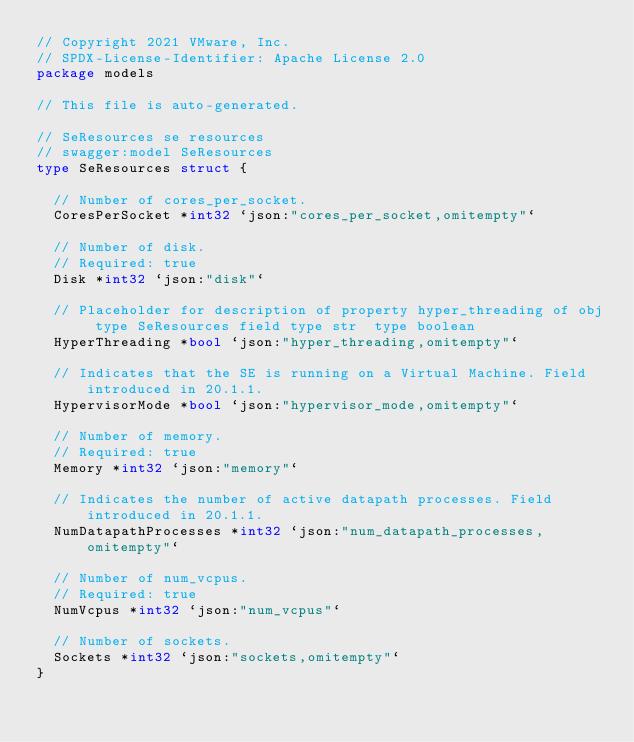Convert code to text. <code><loc_0><loc_0><loc_500><loc_500><_Go_>// Copyright 2021 VMware, Inc.
// SPDX-License-Identifier: Apache License 2.0
package models

// This file is auto-generated.

// SeResources se resources
// swagger:model SeResources
type SeResources struct {

	// Number of cores_per_socket.
	CoresPerSocket *int32 `json:"cores_per_socket,omitempty"`

	// Number of disk.
	// Required: true
	Disk *int32 `json:"disk"`

	// Placeholder for description of property hyper_threading of obj type SeResources field type str  type boolean
	HyperThreading *bool `json:"hyper_threading,omitempty"`

	// Indicates that the SE is running on a Virtual Machine. Field introduced in 20.1.1.
	HypervisorMode *bool `json:"hypervisor_mode,omitempty"`

	// Number of memory.
	// Required: true
	Memory *int32 `json:"memory"`

	// Indicates the number of active datapath processes. Field introduced in 20.1.1.
	NumDatapathProcesses *int32 `json:"num_datapath_processes,omitempty"`

	// Number of num_vcpus.
	// Required: true
	NumVcpus *int32 `json:"num_vcpus"`

	// Number of sockets.
	Sockets *int32 `json:"sockets,omitempty"`
}
</code> 